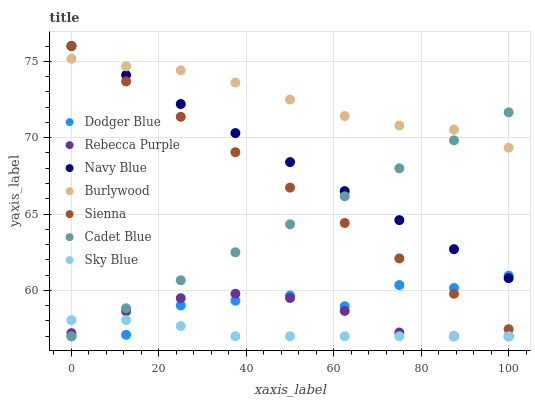Does Sky Blue have the minimum area under the curve?
Answer yes or no. Yes. Does Burlywood have the maximum area under the curve?
Answer yes or no. Yes. Does Navy Blue have the minimum area under the curve?
Answer yes or no. No. Does Navy Blue have the maximum area under the curve?
Answer yes or no. No. Is Cadet Blue the smoothest?
Answer yes or no. Yes. Is Dodger Blue the roughest?
Answer yes or no. Yes. Is Burlywood the smoothest?
Answer yes or no. No. Is Burlywood the roughest?
Answer yes or no. No. Does Cadet Blue have the lowest value?
Answer yes or no. Yes. Does Navy Blue have the lowest value?
Answer yes or no. No. Does Sienna have the highest value?
Answer yes or no. Yes. Does Burlywood have the highest value?
Answer yes or no. No. Is Sky Blue less than Navy Blue?
Answer yes or no. Yes. Is Navy Blue greater than Rebecca Purple?
Answer yes or no. Yes. Does Dodger Blue intersect Sky Blue?
Answer yes or no. Yes. Is Dodger Blue less than Sky Blue?
Answer yes or no. No. Is Dodger Blue greater than Sky Blue?
Answer yes or no. No. Does Sky Blue intersect Navy Blue?
Answer yes or no. No. 